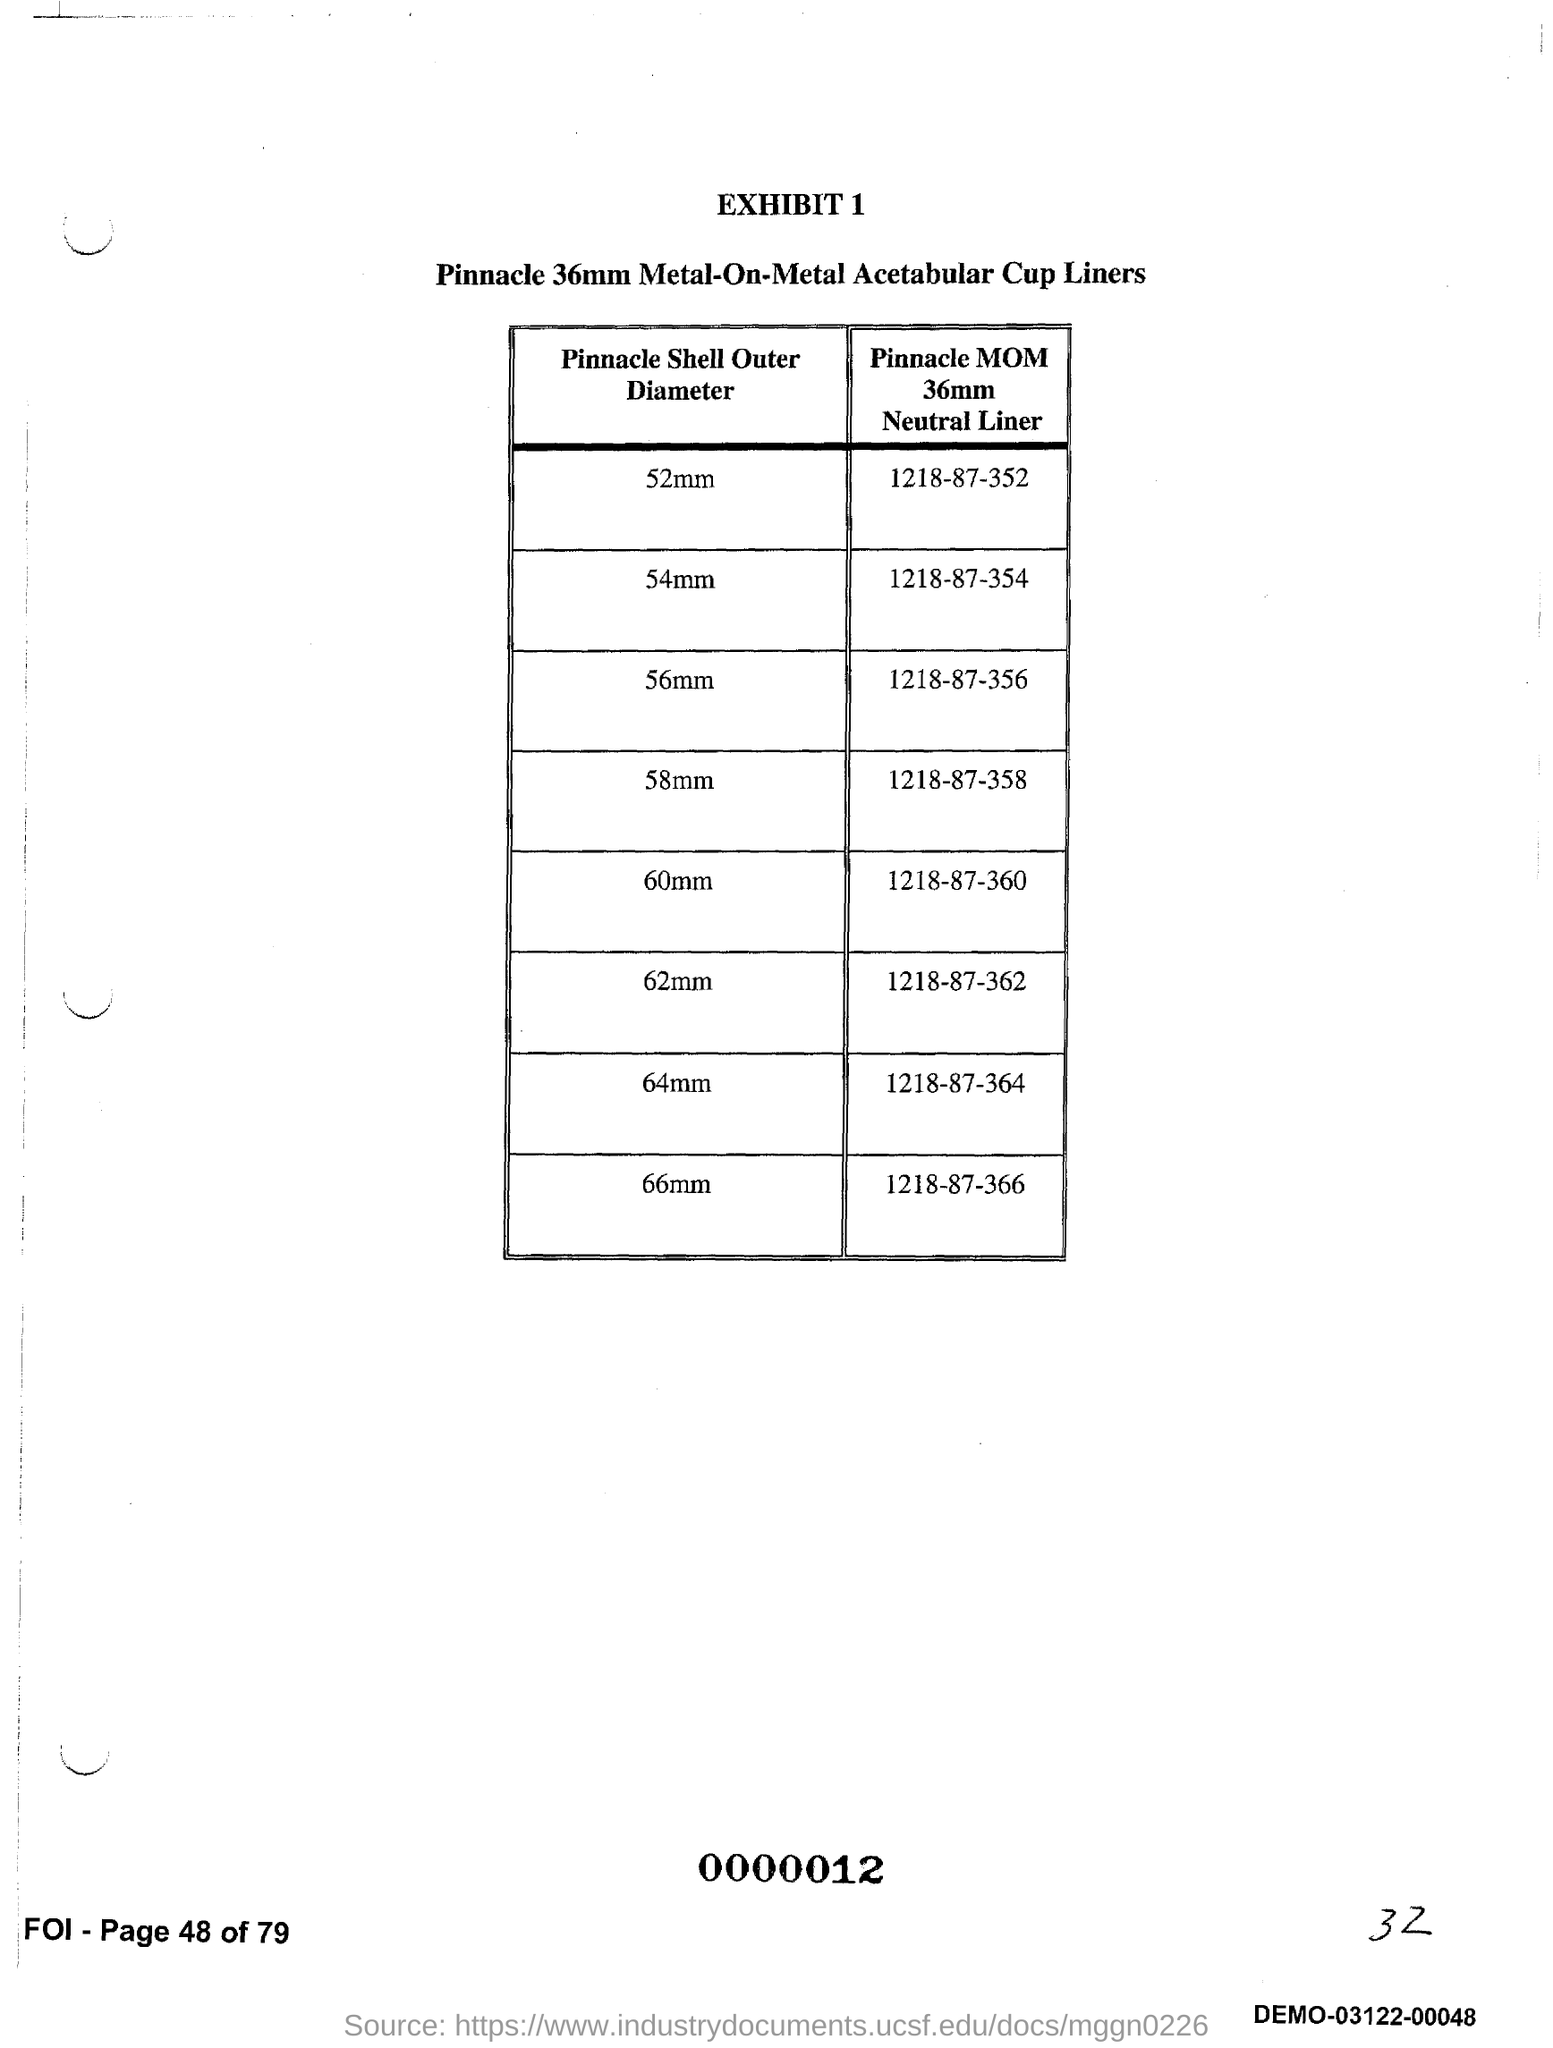What is the Exhibit number?
Make the answer very short. 1. 